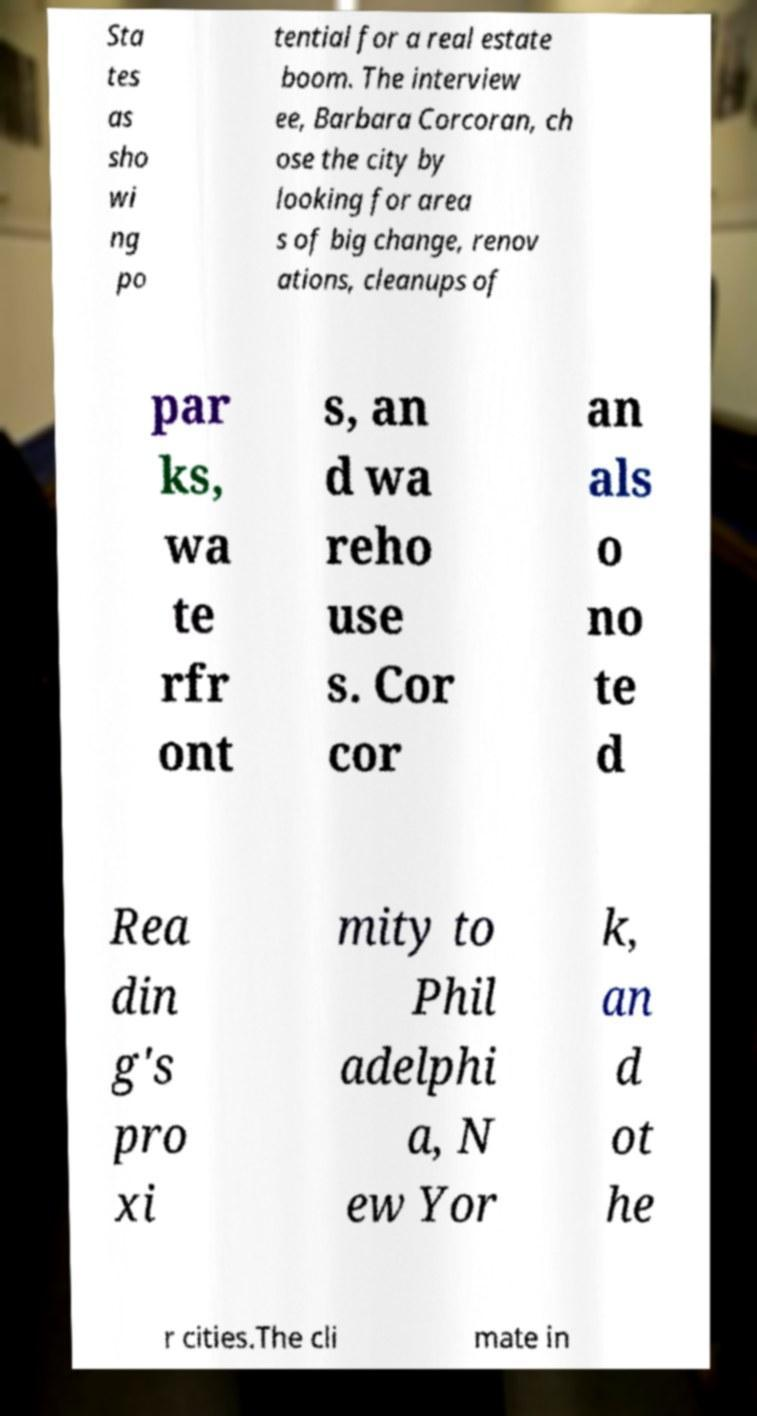Can you read and provide the text displayed in the image?This photo seems to have some interesting text. Can you extract and type it out for me? Sta tes as sho wi ng po tential for a real estate boom. The interview ee, Barbara Corcoran, ch ose the city by looking for area s of big change, renov ations, cleanups of par ks, wa te rfr ont s, an d wa reho use s. Cor cor an als o no te d Rea din g's pro xi mity to Phil adelphi a, N ew Yor k, an d ot he r cities.The cli mate in 